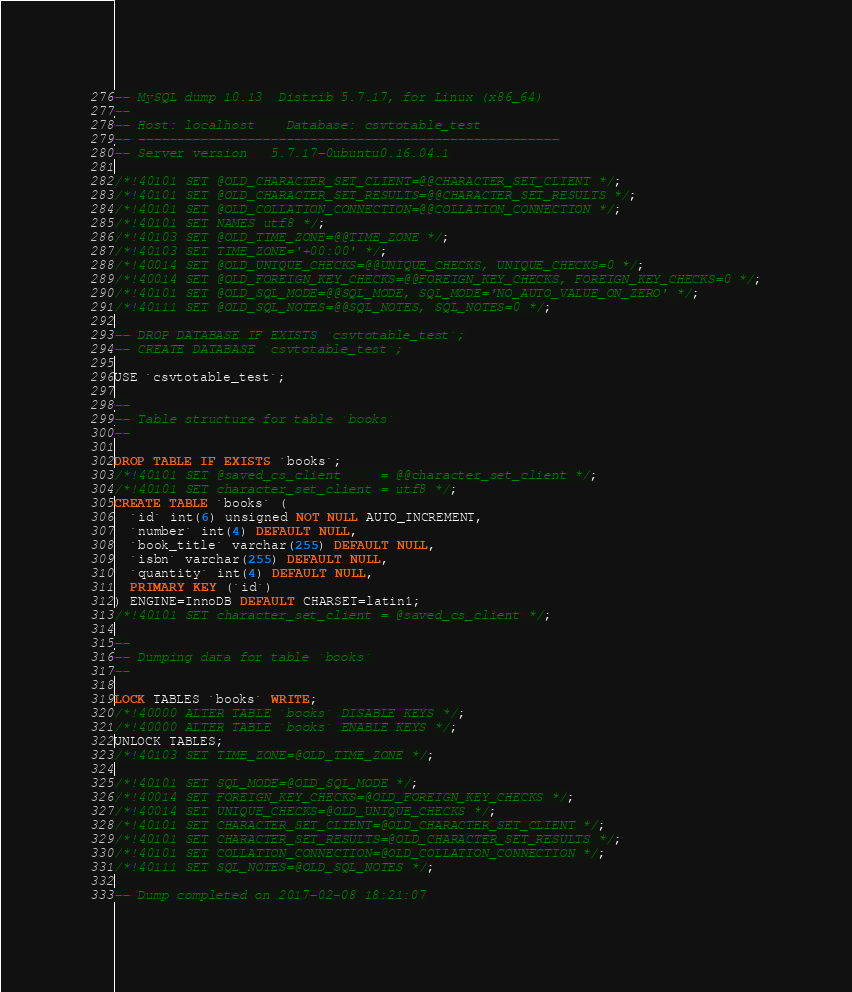Convert code to text. <code><loc_0><loc_0><loc_500><loc_500><_SQL_>-- MySQL dump 10.13  Distrib 5.7.17, for Linux (x86_64)
--
-- Host: localhost    Database: csvtotable_test
-- ------------------------------------------------------
-- Server version	5.7.17-0ubuntu0.16.04.1

/*!40101 SET @OLD_CHARACTER_SET_CLIENT=@@CHARACTER_SET_CLIENT */;
/*!40101 SET @OLD_CHARACTER_SET_RESULTS=@@CHARACTER_SET_RESULTS */;
/*!40101 SET @OLD_COLLATION_CONNECTION=@@COLLATION_CONNECTION */;
/*!40101 SET NAMES utf8 */;
/*!40103 SET @OLD_TIME_ZONE=@@TIME_ZONE */;
/*!40103 SET TIME_ZONE='+00:00' */;
/*!40014 SET @OLD_UNIQUE_CHECKS=@@UNIQUE_CHECKS, UNIQUE_CHECKS=0 */;
/*!40014 SET @OLD_FOREIGN_KEY_CHECKS=@@FOREIGN_KEY_CHECKS, FOREIGN_KEY_CHECKS=0 */;
/*!40101 SET @OLD_SQL_MODE=@@SQL_MODE, SQL_MODE='NO_AUTO_VALUE_ON_ZERO' */;
/*!40111 SET @OLD_SQL_NOTES=@@SQL_NOTES, SQL_NOTES=0 */;

-- DROP DATABASE IF EXISTS `csvtotable_test`;
-- CREATE DATABASE `csvtotable_test`;

USE `csvtotable_test`;

--
-- Table structure for table `books`
--

DROP TABLE IF EXISTS `books`;
/*!40101 SET @saved_cs_client     = @@character_set_client */;
/*!40101 SET character_set_client = utf8 */;
CREATE TABLE `books` (
  `id` int(6) unsigned NOT NULL AUTO_INCREMENT,
  `number` int(4) DEFAULT NULL,
  `book_title` varchar(255) DEFAULT NULL,
  `isbn` varchar(255) DEFAULT NULL,
  `quantity` int(4) DEFAULT NULL,
  PRIMARY KEY (`id`)
) ENGINE=InnoDB DEFAULT CHARSET=latin1;
/*!40101 SET character_set_client = @saved_cs_client */;

--
-- Dumping data for table `books`
--

LOCK TABLES `books` WRITE;
/*!40000 ALTER TABLE `books` DISABLE KEYS */;
/*!40000 ALTER TABLE `books` ENABLE KEYS */;
UNLOCK TABLES;
/*!40103 SET TIME_ZONE=@OLD_TIME_ZONE */;

/*!40101 SET SQL_MODE=@OLD_SQL_MODE */;
/*!40014 SET FOREIGN_KEY_CHECKS=@OLD_FOREIGN_KEY_CHECKS */;
/*!40014 SET UNIQUE_CHECKS=@OLD_UNIQUE_CHECKS */;
/*!40101 SET CHARACTER_SET_CLIENT=@OLD_CHARACTER_SET_CLIENT */;
/*!40101 SET CHARACTER_SET_RESULTS=@OLD_CHARACTER_SET_RESULTS */;
/*!40101 SET COLLATION_CONNECTION=@OLD_COLLATION_CONNECTION */;
/*!40111 SET SQL_NOTES=@OLD_SQL_NOTES */;

-- Dump completed on 2017-02-08 18:21:07
</code> 